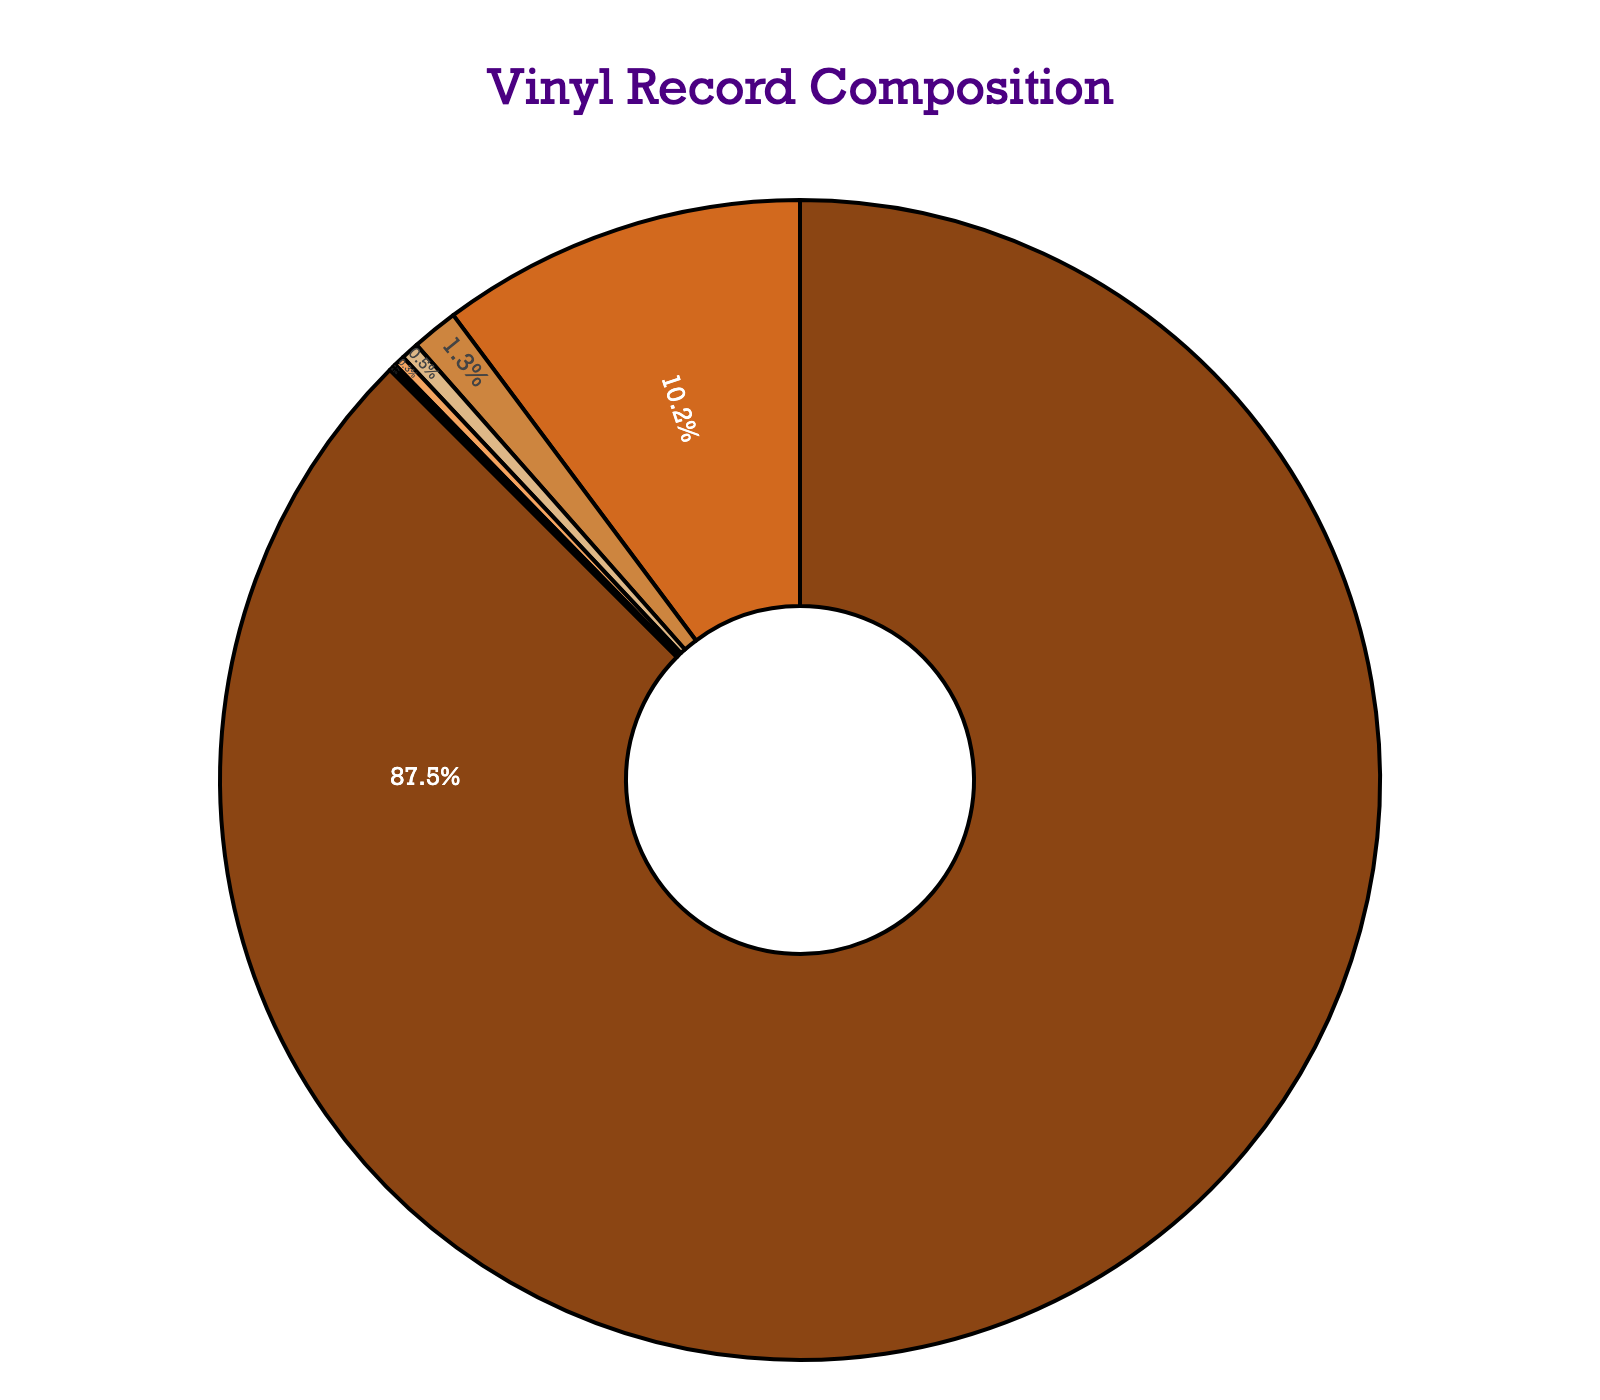What's the primary material used in vintage vinyl record production? The largest section of the pie chart, marked with a visually dominant color (likely brown), represents the primary material. The chart indicates that Polyvinyl Chloride (PVC) occupies 87.5%, which is the highest value among all materials.
Answer: Polyvinyl Chloride (PVC) Which material contributes the least to the composition of vintage vinyl records? The smallest section of the pie chart—with a very thin slice—represents the least contributing material. Both Antistatic Agents and Pigments are tied at the smallest percentage, which is 0.1%.
Answer: Antistatic Agents and Pigments How much more PVC is used compared to Carbon Black? Subtract the percentage of Carbon Black (10.2%) from the percentage of PVC (87.5%). The calculation is 87.5 - 10.2 = 77.3%.
Answer: 77.3% Are the total percentages of Stabilizers, Plasticizers, and Lubricants less than the percentage of Carbon Black? Add the percentages of Stabilizers (1.3%), Plasticizers (0.5%), and Lubricants (0.3%) to get their combined percentage: 1.3 + 0.5 + 0.3 = 2.1%. Since 2.1% is less than Carbon Black’s 10.2%, it's true.
Answer: Yes What's the combined percentage of all materials other than PVC? Sum the percentages of all materials excluding PVC: 10.2 (Carbon Black) + 1.3 (Stabilizers) + 0.5 (Plasticizers) + 0.3 (Lubricants) + 0.1 (Antistatic Agents) + 0.1 (Pigments). This is 10.2 + 1.3 + 0.5 + 0.3 + 0.1 + 0.1 = 12.5%.
Answer: 12.5% Which material has a percentage closest to 1%? The chart shows the percentages and labels close together. The material Stabilizers has a percentage of 1.3%, which is nearest to 1%.
Answer: Stabilizers Compare the combined percentage of Plasticizers and Lubricants with the percentage of Carbon Black. First, add the percentages of Plasticizers (0.5%) and Lubricants (0.3%): 0.5 + 0.3 = 0.8%. Then, compare this result with Carbon Black’s percentage of 10.2%. 0.8% is significantly less than 10.2%.
Answer: Less than Which sections of the chart are visually the same size? Look for slices with identical percentages. Antistatic Agents and Pigments both occupy 0.1% each, hence appear as similarly sized thin slices.
Answer: Antistatic Agents and Pigments What color represents the largest segment in the pie chart? The largest segment (Polyvinyl Chloride) is visually distinguished by a dominant color. In this case, it's marked with the brown color tone from the palette provided.
Answer: Brown Which materials added together precisely match the percentage of PVC? The combined percentage of all segments must add up to 100%, and PVC alone occupies 87.5%, leaving 12.5% for all other materials combined. Adding details: 10.2 (Carbon Black) + 1.3 (Stabilizers) + 0.5 (Plasticizers) + 0.3 (Lubricants) + 0.1 (Antistatic Agents) + 0.1 (Pigments) = 12.5%. So, it matches PVC's 87.5%, as discussed earlier.
Answer: None 